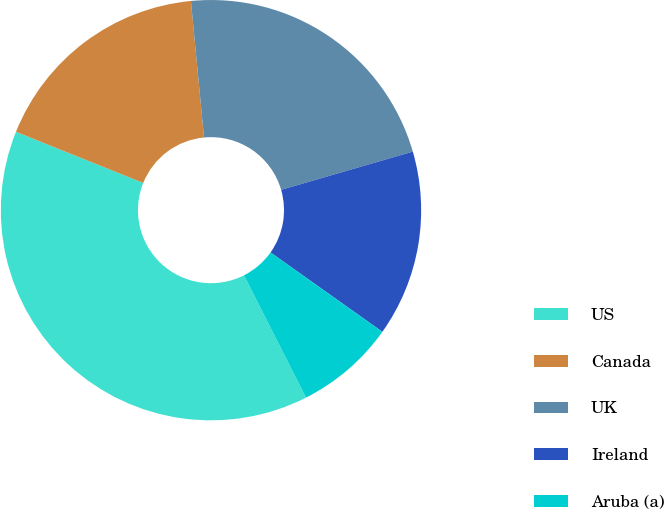Convert chart to OTSL. <chart><loc_0><loc_0><loc_500><loc_500><pie_chart><fcel>US<fcel>Canada<fcel>UK<fcel>Ireland<fcel>Aruba (a)<nl><fcel>38.55%<fcel>17.4%<fcel>22.03%<fcel>14.32%<fcel>7.71%<nl></chart> 